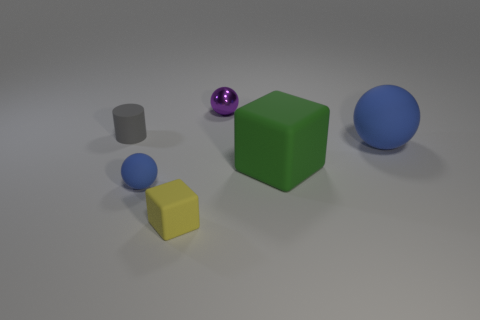What shape is the tiny matte thing that is the same color as the large sphere?
Ensure brevity in your answer.  Sphere. Is there a small gray rubber thing that has the same shape as the big blue matte thing?
Provide a succinct answer. No. What number of tiny rubber objects are to the left of the thing that is left of the matte ball that is left of the small matte cube?
Provide a short and direct response. 0. There is a metal ball; does it have the same color as the cube that is behind the yellow block?
Your response must be concise. No. How many objects are either blue things behind the green block or cubes that are on the left side of the big green rubber cube?
Make the answer very short. 2. Are there more tiny yellow matte objects that are behind the tiny purple metal object than yellow matte blocks to the left of the tiny rubber block?
Ensure brevity in your answer.  No. The blue thing that is on the left side of the tiny ball that is right of the tiny blue object on the right side of the gray rubber object is made of what material?
Give a very brief answer. Rubber. There is a blue object that is left of the purple shiny sphere; is it the same shape as the blue thing that is right of the small purple shiny ball?
Provide a succinct answer. Yes. Is there a metal object that has the same size as the cylinder?
Your answer should be very brief. Yes. How many red things are small cubes or small rubber cylinders?
Provide a short and direct response. 0. 